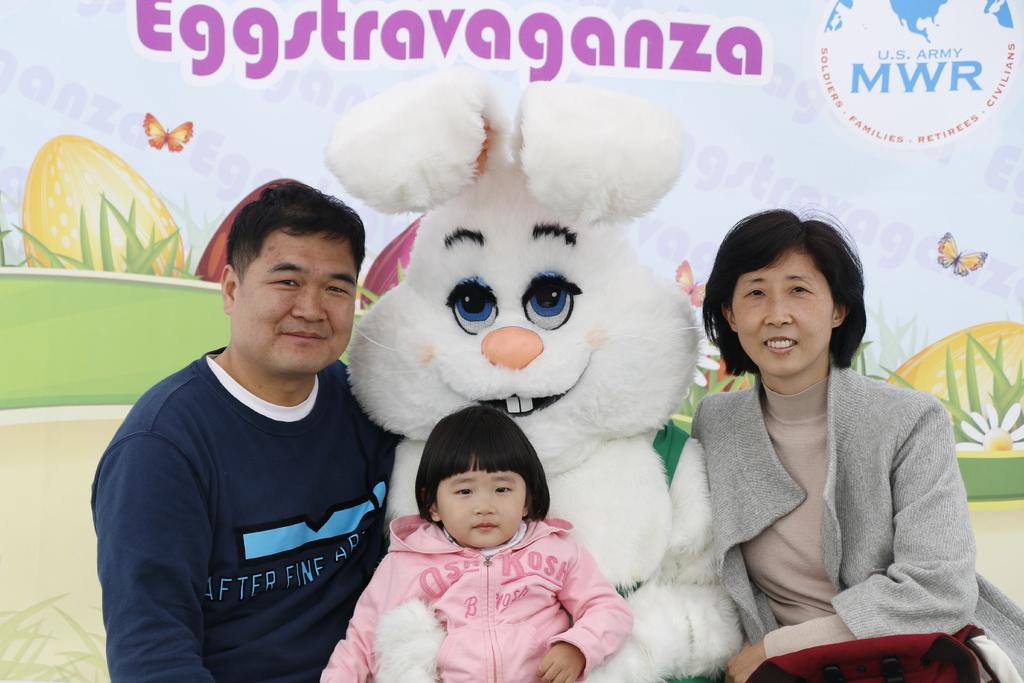How would you summarize this image in a sentence or two? In the image there is a man,woman and a baby standing on either of a rabbit toy and behind them there is a banner on the wall. 